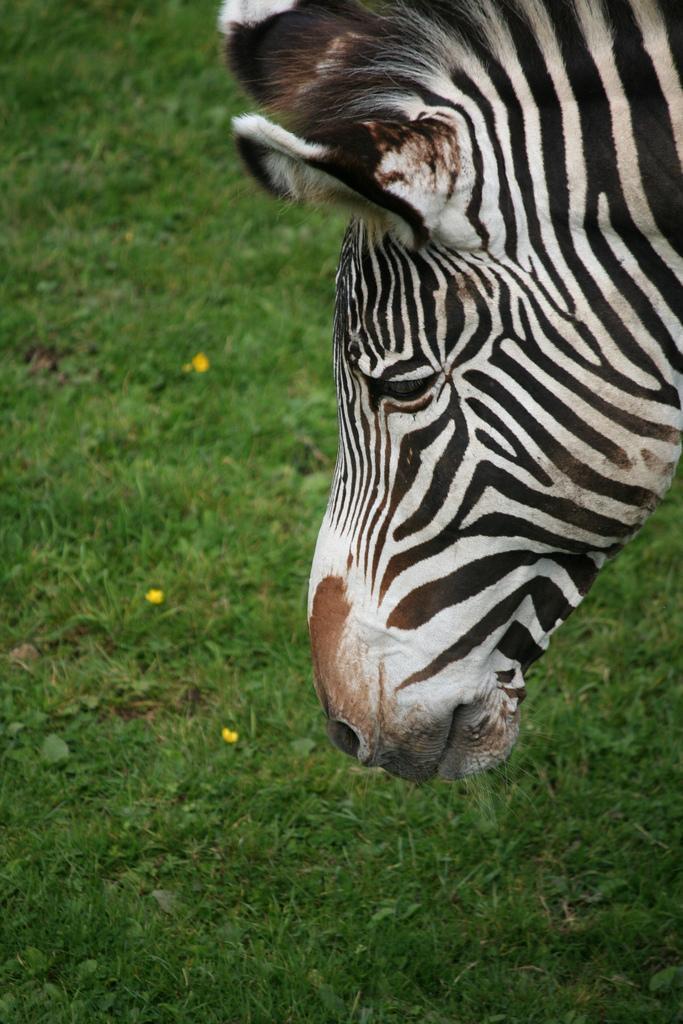How many animals are in the photo?
Give a very brief answer. 1. How many zebras are in the photo?
Give a very brief answer. 1. How many eyes are visible?
Give a very brief answer. 1. How many mouths are there?
Give a very brief answer. 1. How many colors are in this animal's stripes?
Give a very brief answer. 2. How many yellow flowers are visible?
Give a very brief answer. 3. How many ears are visible in the photo?
Give a very brief answer. 1. How many flowers are seen?
Give a very brief answer. 3. How many zebra are in the shot?
Give a very brief answer. 1. 